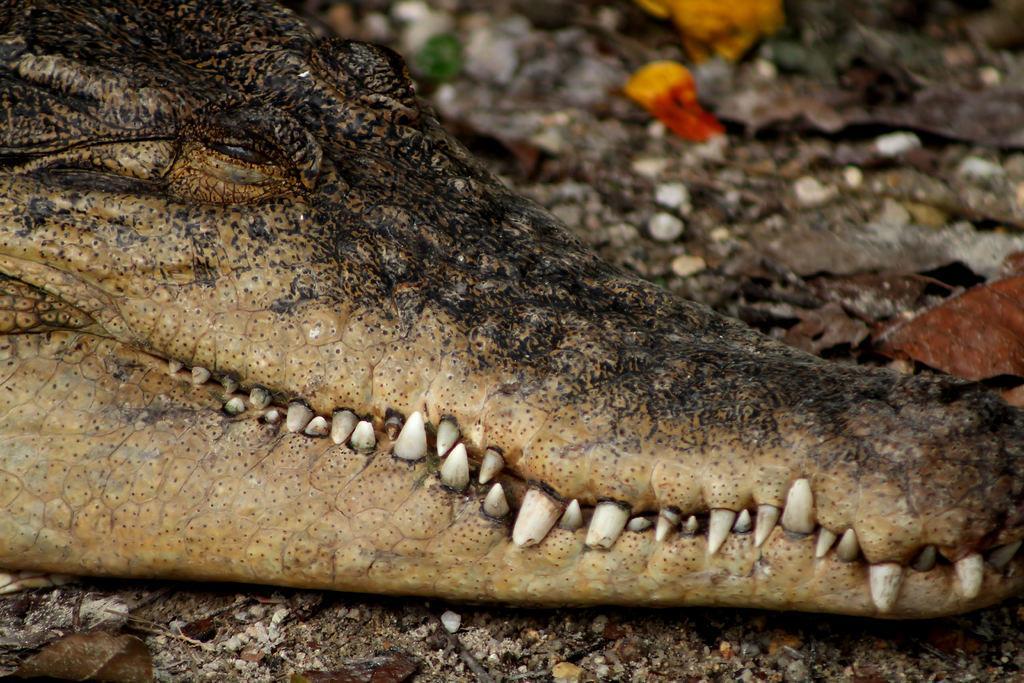Could you give a brief overview of what you see in this image? In this image, we can see a crocodile which is on the land. 